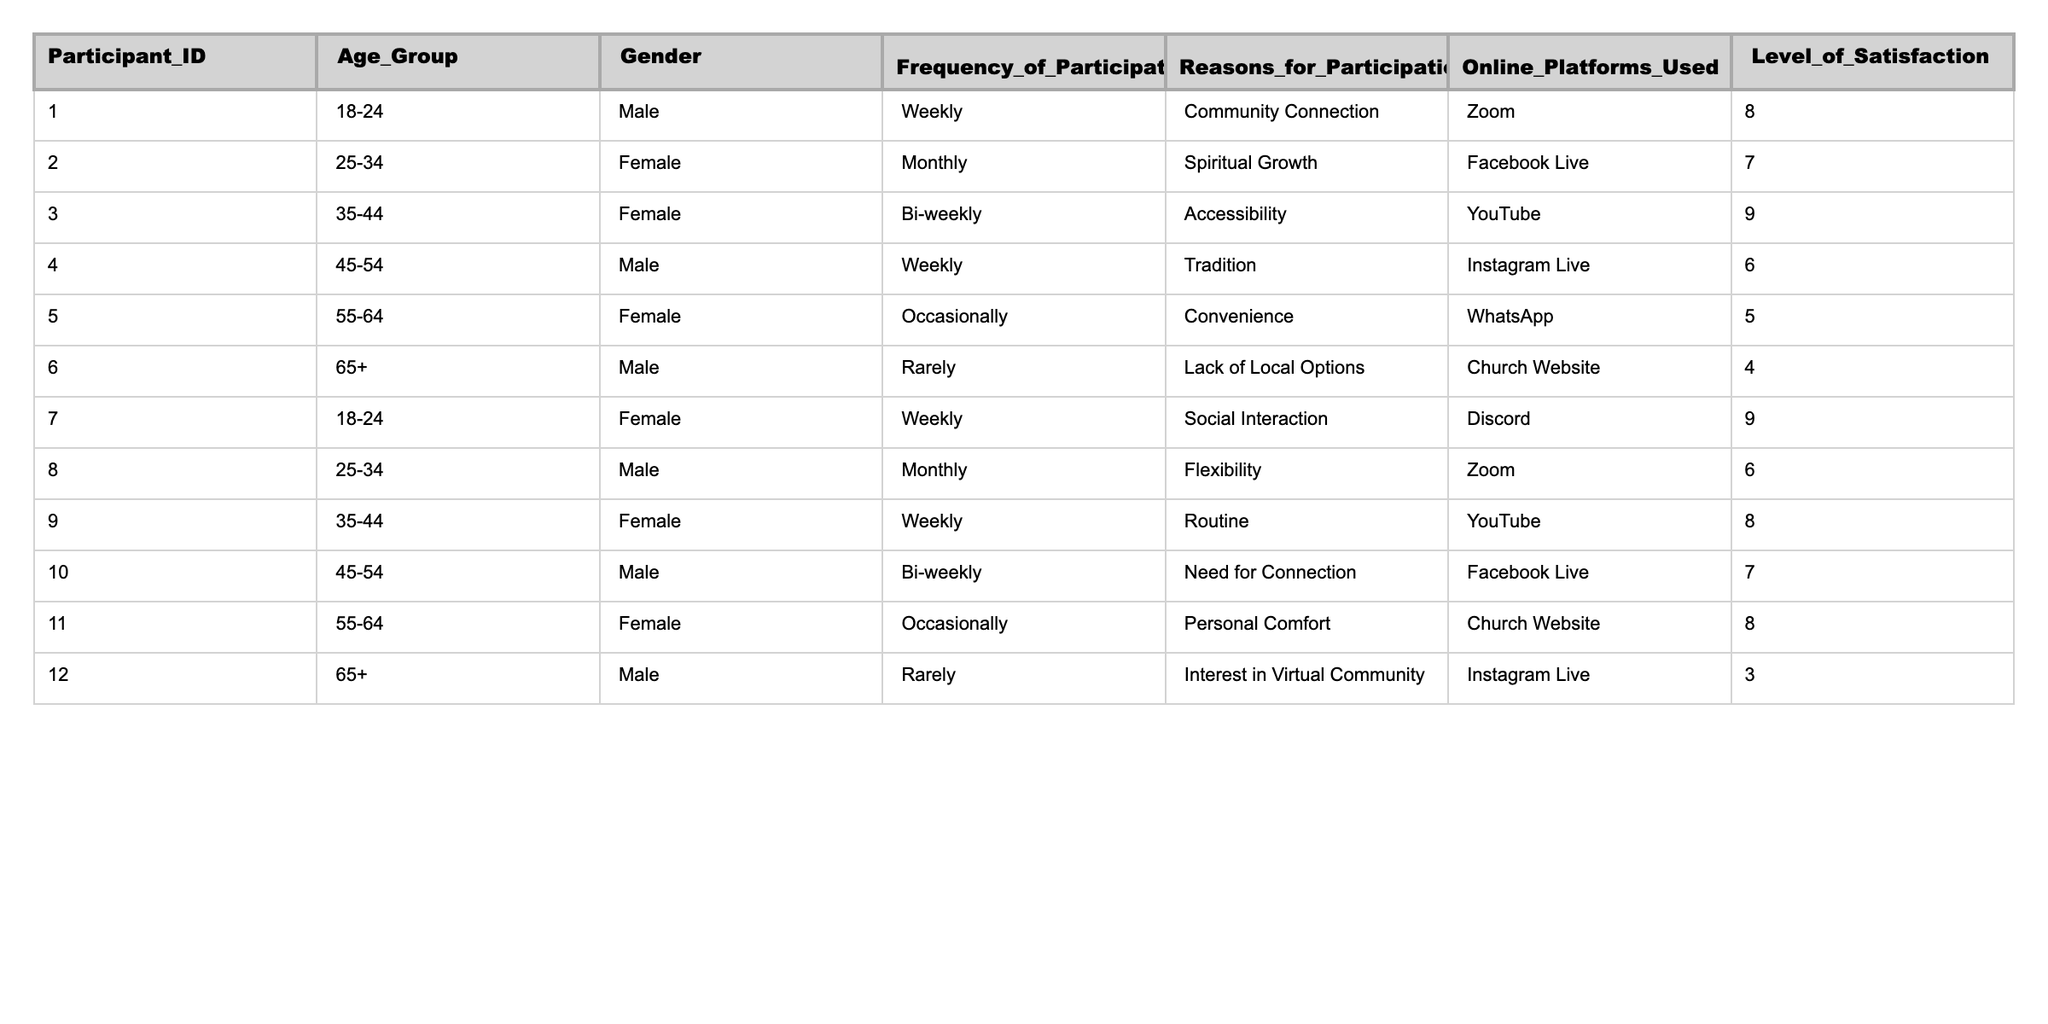What is the most common frequency of participation? To determine the most common frequency, we can count the occurrences for each frequency of participation listed. "Weekly" appears 5 times, "Monthly" 3 times, "Bi-weekly" 2 times, "Occasionally" 2 times, and "Rarely" 3 times. Thus, "Weekly" is the most common.
Answer: Weekly What is the average level of satisfaction for participants aged 18-24? We need to look at the levels of satisfaction for the participants in the 18-24 age group. They are 8 (Participant 1) and 9 (Participant 7). The average is calculated as (8 + 9) / 2 = 17 / 2 = 8.5.
Answer: 8.5 True or False: All male participants prefer Zoom as their online platform. By looking at the online platforms used by male participants (identified as Participant 1, 4, 6, 8, 10, 12), we see that only Participant 1 and Participant 8 use Zoom. Other males use different platforms, so this statement is false.
Answer: False How does the level of satisfaction correlate with the reasons for participation among participants who attend weekly? For weekly participants, we assess the levels of satisfaction: Participant 1 (8, Community Connection), Participant 7 (9, Social Interaction), and Participant 9 (8, Routine). All participants attending weekly report high levels of satisfaction (≥8), indicating a positive correlation between satisfaction and reasons for participation.
Answer: Positive correlation What is the total number of participants who use YouTube as their online platform, and how does their average frequency of participation compare to others? We find that Participants 3 and 9 use YouTube, totaling 2 participants. Their frequencies are Bi-weekly (Participant 3) and Weekly (Participant 9). The average frequency position is further calculated, with more weighting given to the weekly count. Therefore, 2/2 leads to a general frequency of approx. 1.5 (as more frequent attendance skews the average).
Answer: 2 participants, average frequency 1.5 Which age group has the highest average level of satisfaction? We will calculate the average level of satisfaction per age group (18-24, 25-34, 35-44, 45-54, 55-64, 65+). The average for each group is computed, finding that the highest average is in the 18-24 group with 8.5, calculated from participants 1 (8) and 7 (9).
Answer: 18-24 